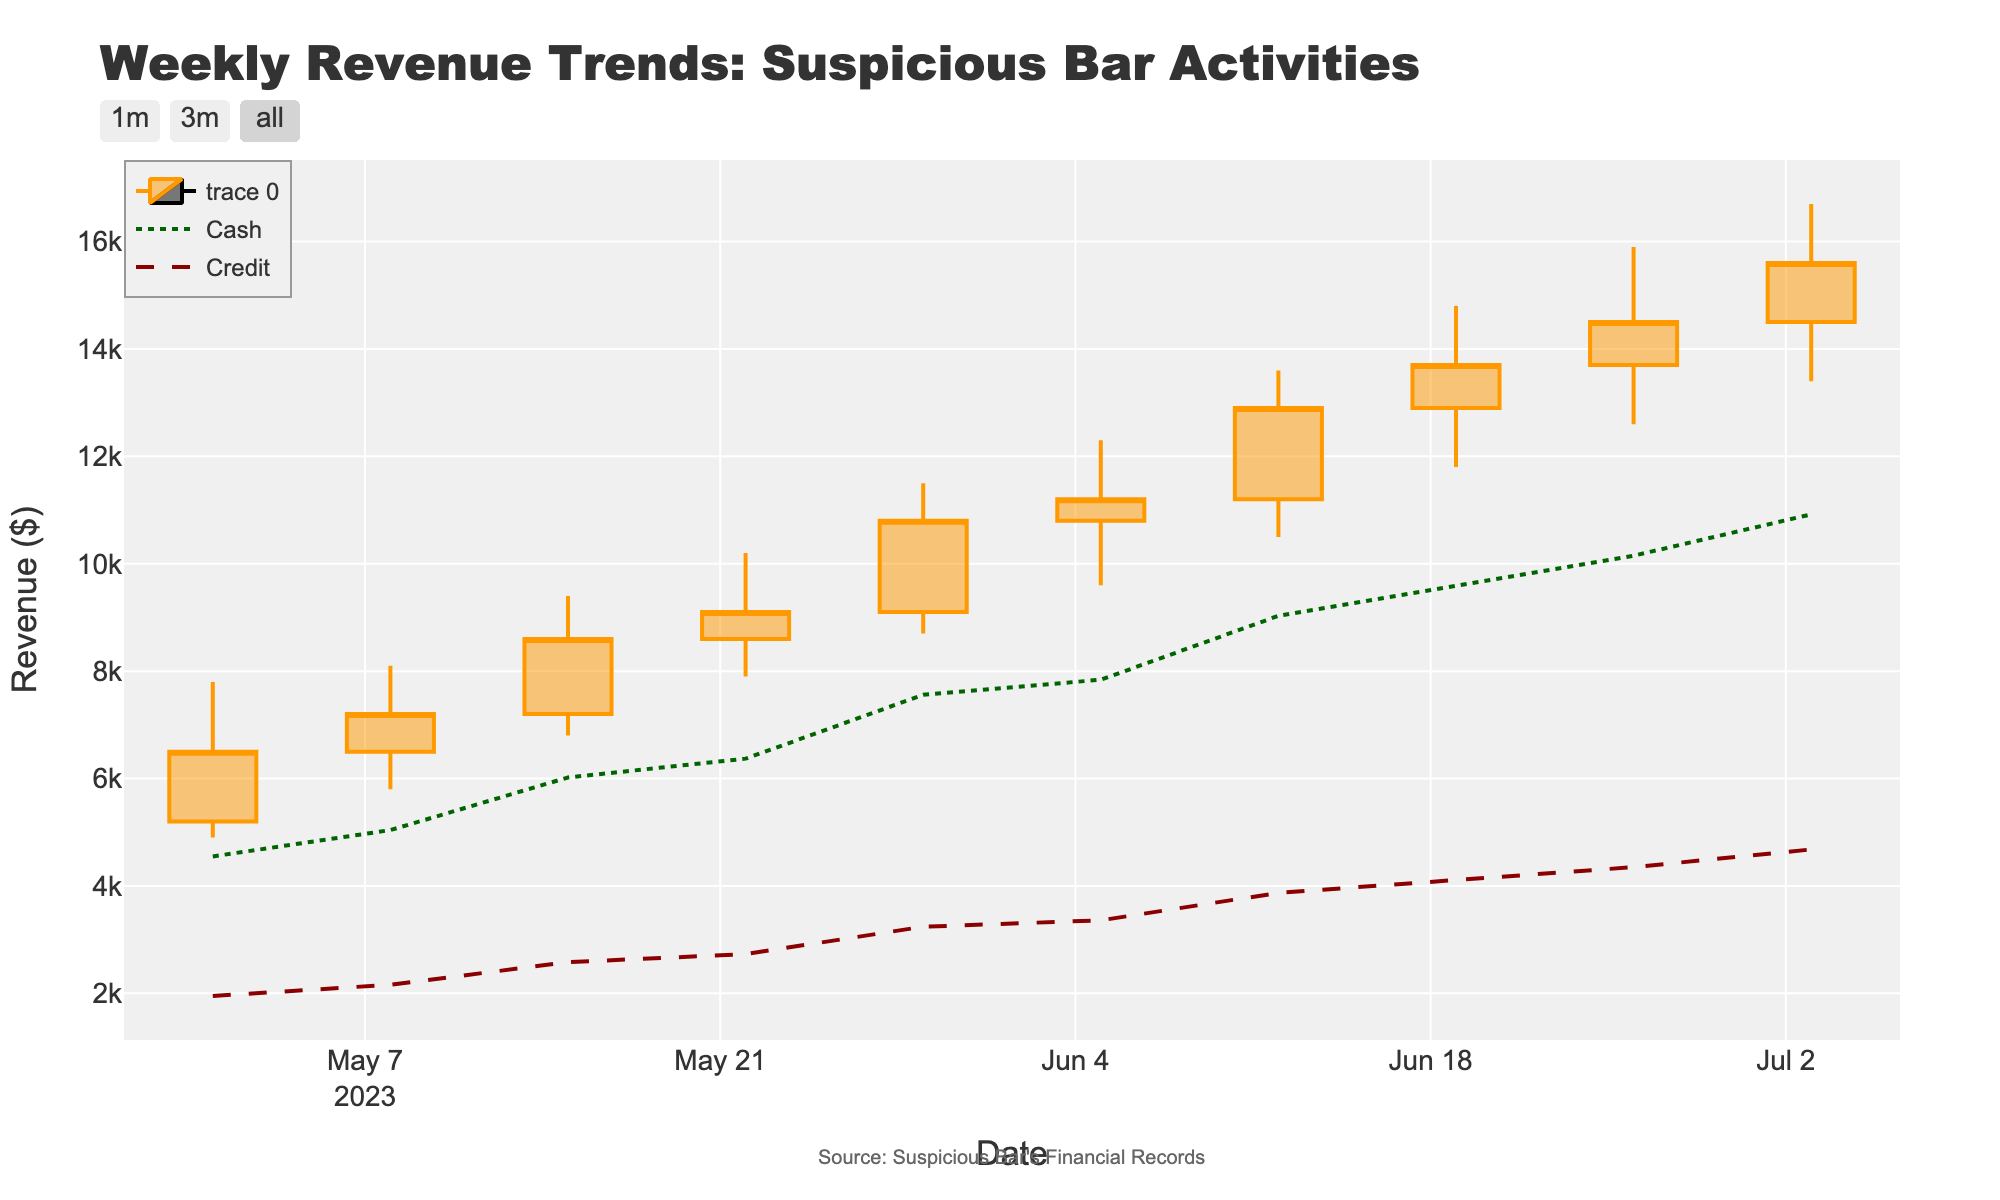What's the title of the figure? The title is positioned at the top of the chart and is clearly stated as "Weekly Revenue Trends: Suspicious Bar Activities"
Answer: Weekly Revenue Trends: Suspicious Bar Activities What is the date range presented in the figure? The date range is displayed along the x-axis from the first to the last tick mark, which span from May 1, 2023, to July 3, 2023
Answer: May 1, 2023, to July 3, 2023 How many weeks of data are shown in the figure? By counting the number of dates along the x-axis, we can see there are data points for 10 weeks
Answer: 10 weeks What is the maximum revenue recorded and in which week did it occur? The maximum revenue is found by looking at the highest point of the "High" element in the OHLC chart, which is $16,700, and it occurs in the week of July 3, 2023
Answer: $16,700 in the week of July 3, 2023 What is the trend of cash transactions from May 1, 2023, to July 3, 2023? By following the green dotted line for cash transactions, we can observe a consistent upward trend across the weeks
Answer: Consistently upward How does the trend of credit transactions compare to cash transactions? By comparing the green dotted line (cash) and the red dashed line (credit), both show an upward trend, but the cash transactions increase at a slightly faster rate
Answer: Both upward; cash faster What was the opening revenue and closing revenue for the week of June 19, 2023? The opening revenue is given by the "Open" value and the closing revenue by the "Close" value for that week, which are $12,900 and $13,700 respectively
Answer: $12,900 and $13,700 During which week did the 'Low' revenue value reach a minimum, and what was that value? The minimum 'Low' value must be identified from the chart’s low points and comparing values, the lowest point is $4,900 in the week of May 1, 2023
Answer: $4,900 in the week of May 1, 2023 What was the average cash transaction amount over the 10 weeks? Summing each week's cash transactions and dividing by the number of weeks: (4550 + 5040 + 6020 + 6370 + 7560 + 7840 + 9030 + 9590 + 10150 + 10920) / 10 = 7607
Answer: $7,607 Which week experienced the highest fluctuation in revenue, and what was this range? The highest fluctuation is found by examining the difference between the 'High' and 'Low' for each week; the largest is $4,800 in the week of June 12, 2023 ($13,600 - $10,500)
Answer: The week of June 12, 2023, with a range of $4,800 